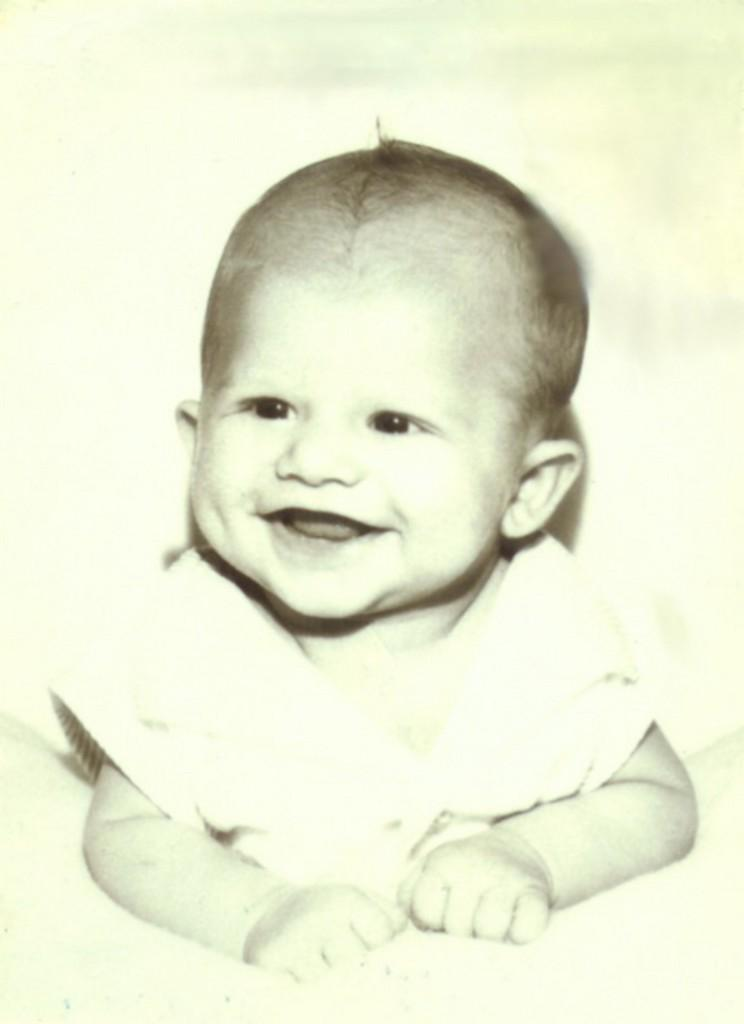What is the main subject of the image? There is a baby in the image. Where is the baby located in the image? The baby is in the center of the image. What is the baby's expression in the image? The baby is smiling. What type of account does the baby have at the zoo in the image? There is no mention of a zoo or an account in the image; it simply features a baby smiling. 